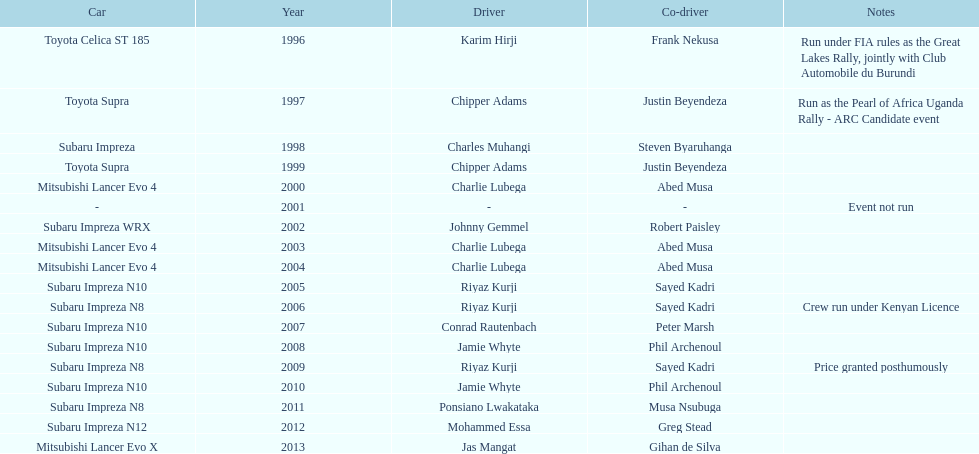How many times was charlie lubega a driver? 3. 